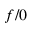Convert formula to latex. <formula><loc_0><loc_0><loc_500><loc_500>f / 0</formula> 